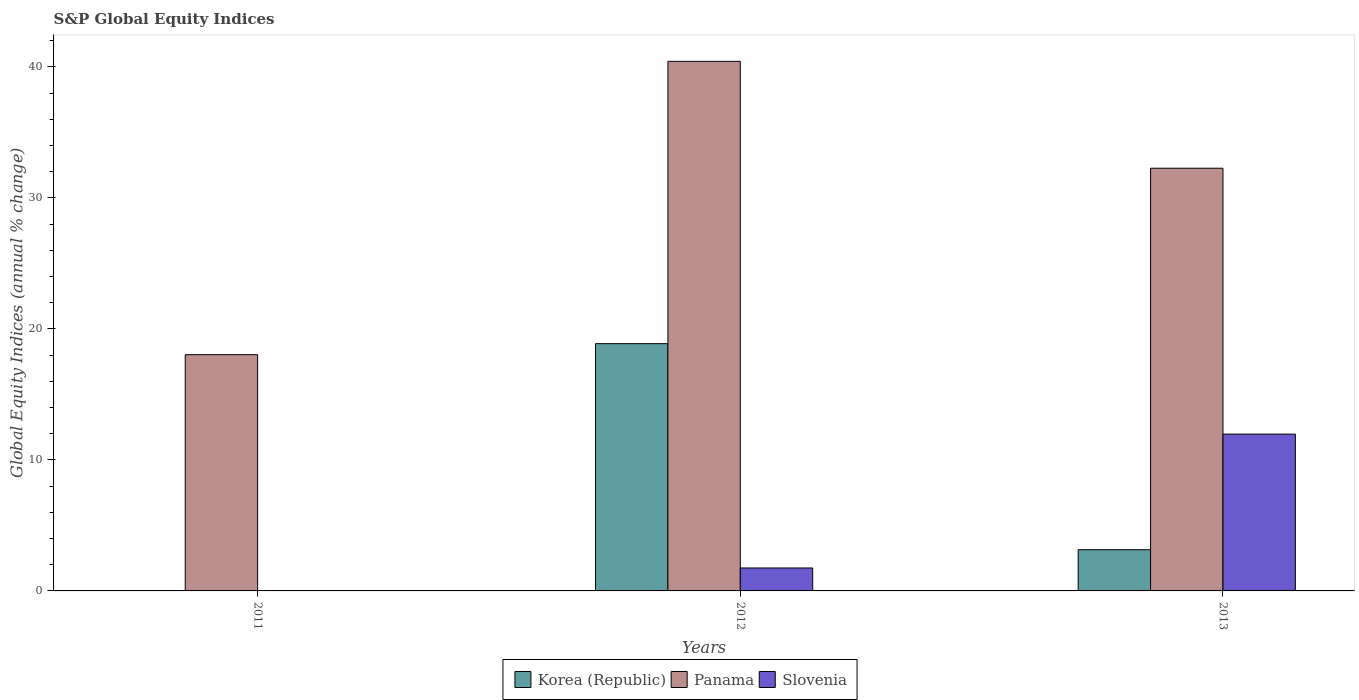Are the number of bars on each tick of the X-axis equal?
Keep it short and to the point. No. How many bars are there on the 1st tick from the left?
Give a very brief answer. 1. How many bars are there on the 1st tick from the right?
Keep it short and to the point. 3. What is the label of the 3rd group of bars from the left?
Provide a short and direct response. 2013. Across all years, what is the maximum global equity indices in Korea (Republic)?
Your response must be concise. 18.88. Across all years, what is the minimum global equity indices in Panama?
Make the answer very short. 18.04. In which year was the global equity indices in Panama maximum?
Offer a terse response. 2012. What is the total global equity indices in Korea (Republic) in the graph?
Give a very brief answer. 22.02. What is the difference between the global equity indices in Panama in 2011 and that in 2013?
Provide a succinct answer. -14.23. What is the difference between the global equity indices in Slovenia in 2012 and the global equity indices in Korea (Republic) in 2013?
Your answer should be compact. -1.4. What is the average global equity indices in Slovenia per year?
Provide a short and direct response. 4.57. In the year 2013, what is the difference between the global equity indices in Panama and global equity indices in Korea (Republic)?
Ensure brevity in your answer.  29.12. What is the ratio of the global equity indices in Panama in 2011 to that in 2012?
Your response must be concise. 0.45. Is the global equity indices in Panama in 2012 less than that in 2013?
Offer a terse response. No. What is the difference between the highest and the second highest global equity indices in Panama?
Provide a succinct answer. 8.16. What is the difference between the highest and the lowest global equity indices in Korea (Republic)?
Provide a short and direct response. 18.88. How many years are there in the graph?
Keep it short and to the point. 3. Are the values on the major ticks of Y-axis written in scientific E-notation?
Your response must be concise. No. Where does the legend appear in the graph?
Give a very brief answer. Bottom center. How many legend labels are there?
Your response must be concise. 3. How are the legend labels stacked?
Offer a terse response. Horizontal. What is the title of the graph?
Your response must be concise. S&P Global Equity Indices. Does "Aruba" appear as one of the legend labels in the graph?
Make the answer very short. No. What is the label or title of the Y-axis?
Give a very brief answer. Global Equity Indices (annual % change). What is the Global Equity Indices (annual % change) in Korea (Republic) in 2011?
Provide a succinct answer. 0. What is the Global Equity Indices (annual % change) of Panama in 2011?
Provide a short and direct response. 18.04. What is the Global Equity Indices (annual % change) in Korea (Republic) in 2012?
Your answer should be very brief. 18.88. What is the Global Equity Indices (annual % change) in Panama in 2012?
Give a very brief answer. 40.43. What is the Global Equity Indices (annual % change) of Slovenia in 2012?
Your answer should be compact. 1.75. What is the Global Equity Indices (annual % change) of Korea (Republic) in 2013?
Your response must be concise. 3.15. What is the Global Equity Indices (annual % change) in Panama in 2013?
Your answer should be very brief. 32.27. What is the Global Equity Indices (annual % change) in Slovenia in 2013?
Provide a short and direct response. 11.97. Across all years, what is the maximum Global Equity Indices (annual % change) of Korea (Republic)?
Give a very brief answer. 18.88. Across all years, what is the maximum Global Equity Indices (annual % change) of Panama?
Offer a terse response. 40.43. Across all years, what is the maximum Global Equity Indices (annual % change) of Slovenia?
Make the answer very short. 11.97. Across all years, what is the minimum Global Equity Indices (annual % change) of Panama?
Give a very brief answer. 18.04. What is the total Global Equity Indices (annual % change) of Korea (Republic) in the graph?
Provide a succinct answer. 22.02. What is the total Global Equity Indices (annual % change) of Panama in the graph?
Make the answer very short. 90.74. What is the total Global Equity Indices (annual % change) of Slovenia in the graph?
Keep it short and to the point. 13.72. What is the difference between the Global Equity Indices (annual % change) of Panama in 2011 and that in 2012?
Provide a short and direct response. -22.39. What is the difference between the Global Equity Indices (annual % change) in Panama in 2011 and that in 2013?
Your answer should be very brief. -14.23. What is the difference between the Global Equity Indices (annual % change) of Korea (Republic) in 2012 and that in 2013?
Your answer should be very brief. 15.73. What is the difference between the Global Equity Indices (annual % change) in Panama in 2012 and that in 2013?
Your answer should be compact. 8.16. What is the difference between the Global Equity Indices (annual % change) in Slovenia in 2012 and that in 2013?
Give a very brief answer. -10.22. What is the difference between the Global Equity Indices (annual % change) in Panama in 2011 and the Global Equity Indices (annual % change) in Slovenia in 2012?
Provide a short and direct response. 16.29. What is the difference between the Global Equity Indices (annual % change) in Panama in 2011 and the Global Equity Indices (annual % change) in Slovenia in 2013?
Provide a succinct answer. 6.07. What is the difference between the Global Equity Indices (annual % change) of Korea (Republic) in 2012 and the Global Equity Indices (annual % change) of Panama in 2013?
Your response must be concise. -13.39. What is the difference between the Global Equity Indices (annual % change) in Korea (Republic) in 2012 and the Global Equity Indices (annual % change) in Slovenia in 2013?
Keep it short and to the point. 6.91. What is the difference between the Global Equity Indices (annual % change) of Panama in 2012 and the Global Equity Indices (annual % change) of Slovenia in 2013?
Give a very brief answer. 28.46. What is the average Global Equity Indices (annual % change) of Korea (Republic) per year?
Offer a terse response. 7.34. What is the average Global Equity Indices (annual % change) in Panama per year?
Make the answer very short. 30.25. What is the average Global Equity Indices (annual % change) in Slovenia per year?
Offer a terse response. 4.57. In the year 2012, what is the difference between the Global Equity Indices (annual % change) of Korea (Republic) and Global Equity Indices (annual % change) of Panama?
Keep it short and to the point. -21.55. In the year 2012, what is the difference between the Global Equity Indices (annual % change) in Korea (Republic) and Global Equity Indices (annual % change) in Slovenia?
Your answer should be compact. 17.13. In the year 2012, what is the difference between the Global Equity Indices (annual % change) in Panama and Global Equity Indices (annual % change) in Slovenia?
Make the answer very short. 38.68. In the year 2013, what is the difference between the Global Equity Indices (annual % change) in Korea (Republic) and Global Equity Indices (annual % change) in Panama?
Make the answer very short. -29.12. In the year 2013, what is the difference between the Global Equity Indices (annual % change) in Korea (Republic) and Global Equity Indices (annual % change) in Slovenia?
Ensure brevity in your answer.  -8.82. In the year 2013, what is the difference between the Global Equity Indices (annual % change) of Panama and Global Equity Indices (annual % change) of Slovenia?
Your response must be concise. 20.3. What is the ratio of the Global Equity Indices (annual % change) in Panama in 2011 to that in 2012?
Your answer should be very brief. 0.45. What is the ratio of the Global Equity Indices (annual % change) of Panama in 2011 to that in 2013?
Keep it short and to the point. 0.56. What is the ratio of the Global Equity Indices (annual % change) in Korea (Republic) in 2012 to that in 2013?
Provide a succinct answer. 6. What is the ratio of the Global Equity Indices (annual % change) in Panama in 2012 to that in 2013?
Your answer should be compact. 1.25. What is the ratio of the Global Equity Indices (annual % change) of Slovenia in 2012 to that in 2013?
Your response must be concise. 0.15. What is the difference between the highest and the second highest Global Equity Indices (annual % change) of Panama?
Your response must be concise. 8.16. What is the difference between the highest and the lowest Global Equity Indices (annual % change) in Korea (Republic)?
Your response must be concise. 18.88. What is the difference between the highest and the lowest Global Equity Indices (annual % change) in Panama?
Offer a very short reply. 22.39. What is the difference between the highest and the lowest Global Equity Indices (annual % change) in Slovenia?
Your response must be concise. 11.97. 